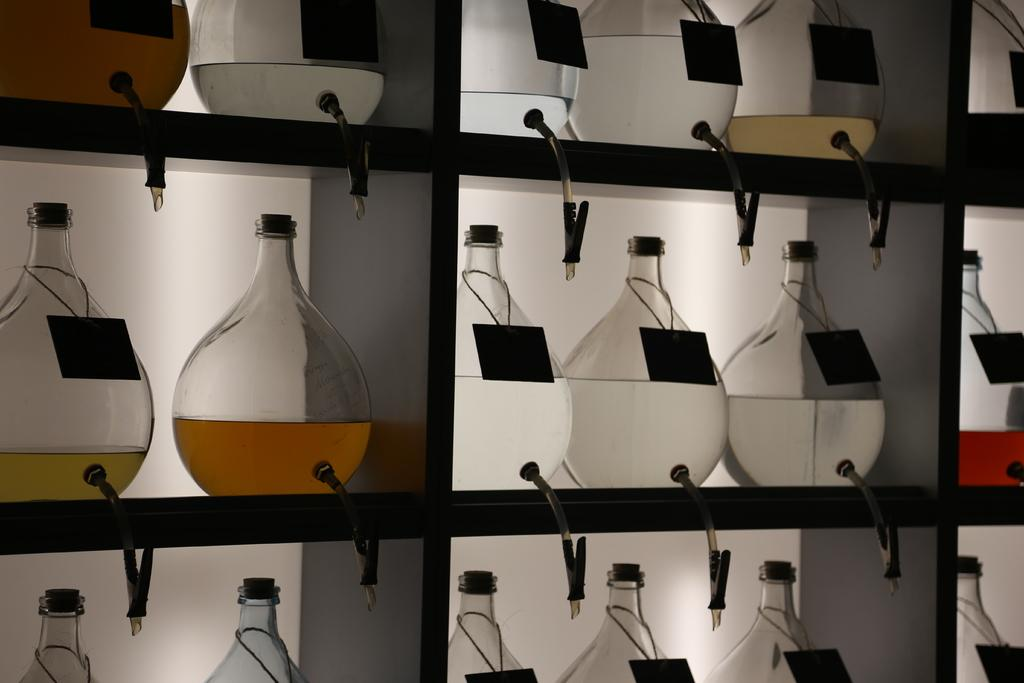What can be seen in the image? There is a rack in the image. What is on the rack? There are spots with liquid on the rack. How many thumbs are visible in the image? There are no thumbs visible in the image. What is the size of the airport in the image? There is no airport present in the image. 